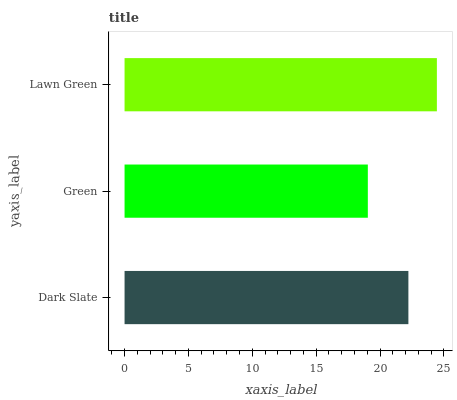Is Green the minimum?
Answer yes or no. Yes. Is Lawn Green the maximum?
Answer yes or no. Yes. Is Lawn Green the minimum?
Answer yes or no. No. Is Green the maximum?
Answer yes or no. No. Is Lawn Green greater than Green?
Answer yes or no. Yes. Is Green less than Lawn Green?
Answer yes or no. Yes. Is Green greater than Lawn Green?
Answer yes or no. No. Is Lawn Green less than Green?
Answer yes or no. No. Is Dark Slate the high median?
Answer yes or no. Yes. Is Dark Slate the low median?
Answer yes or no. Yes. Is Lawn Green the high median?
Answer yes or no. No. Is Green the low median?
Answer yes or no. No. 